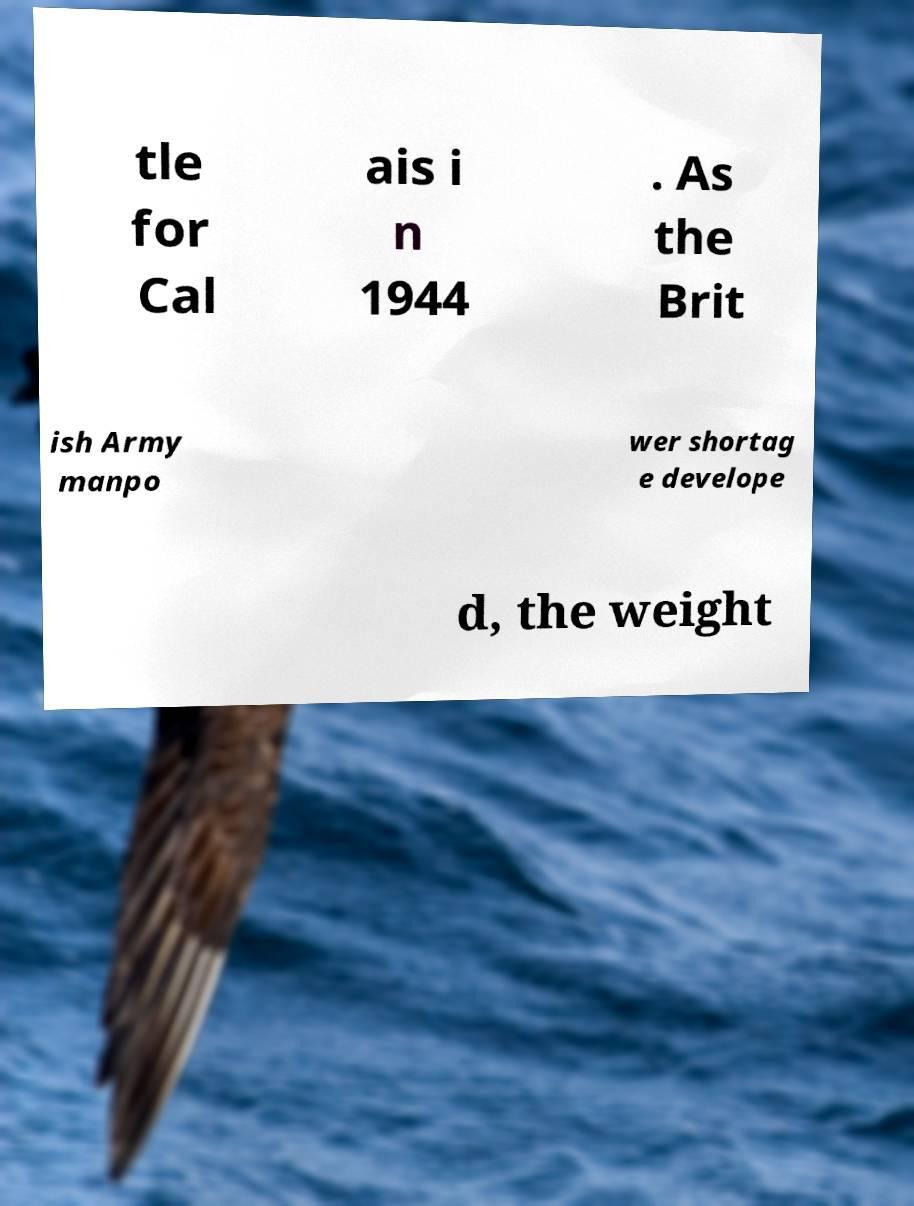Could you extract and type out the text from this image? tle for Cal ais i n 1944 . As the Brit ish Army manpo wer shortag e develope d, the weight 